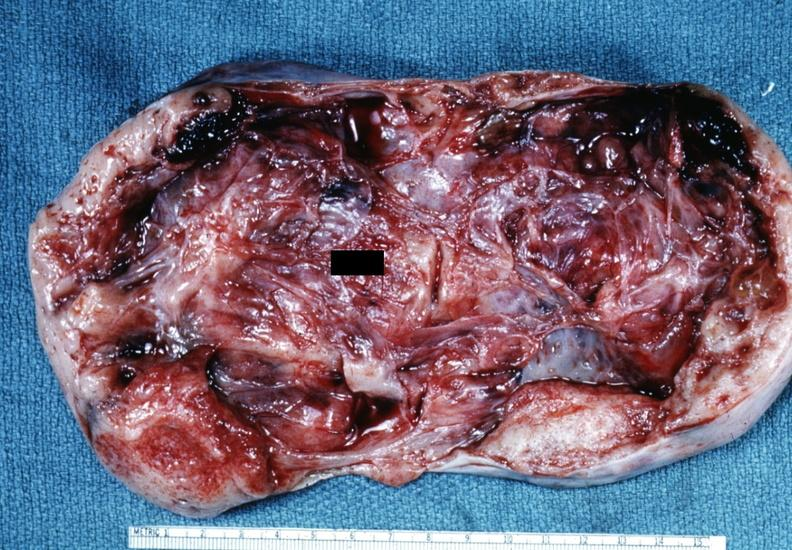what is present?
Answer the question using a single word or phrase. Granulosa cell tumor 